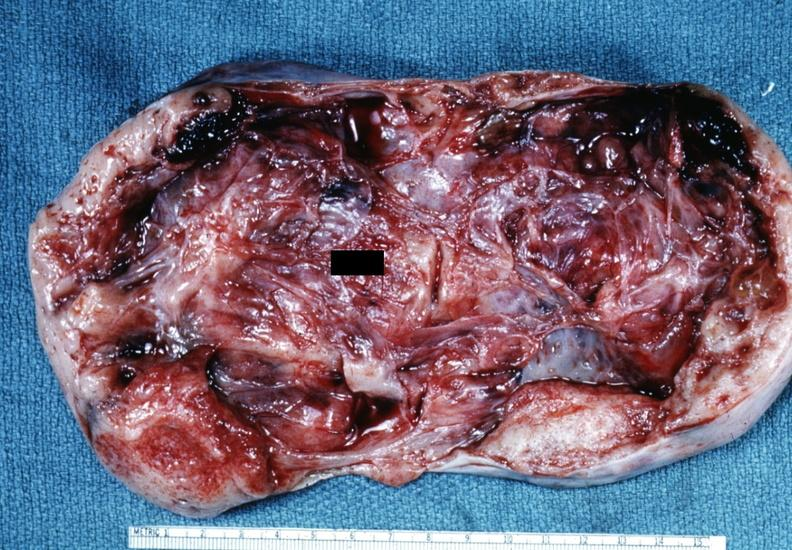what is present?
Answer the question using a single word or phrase. Granulosa cell tumor 